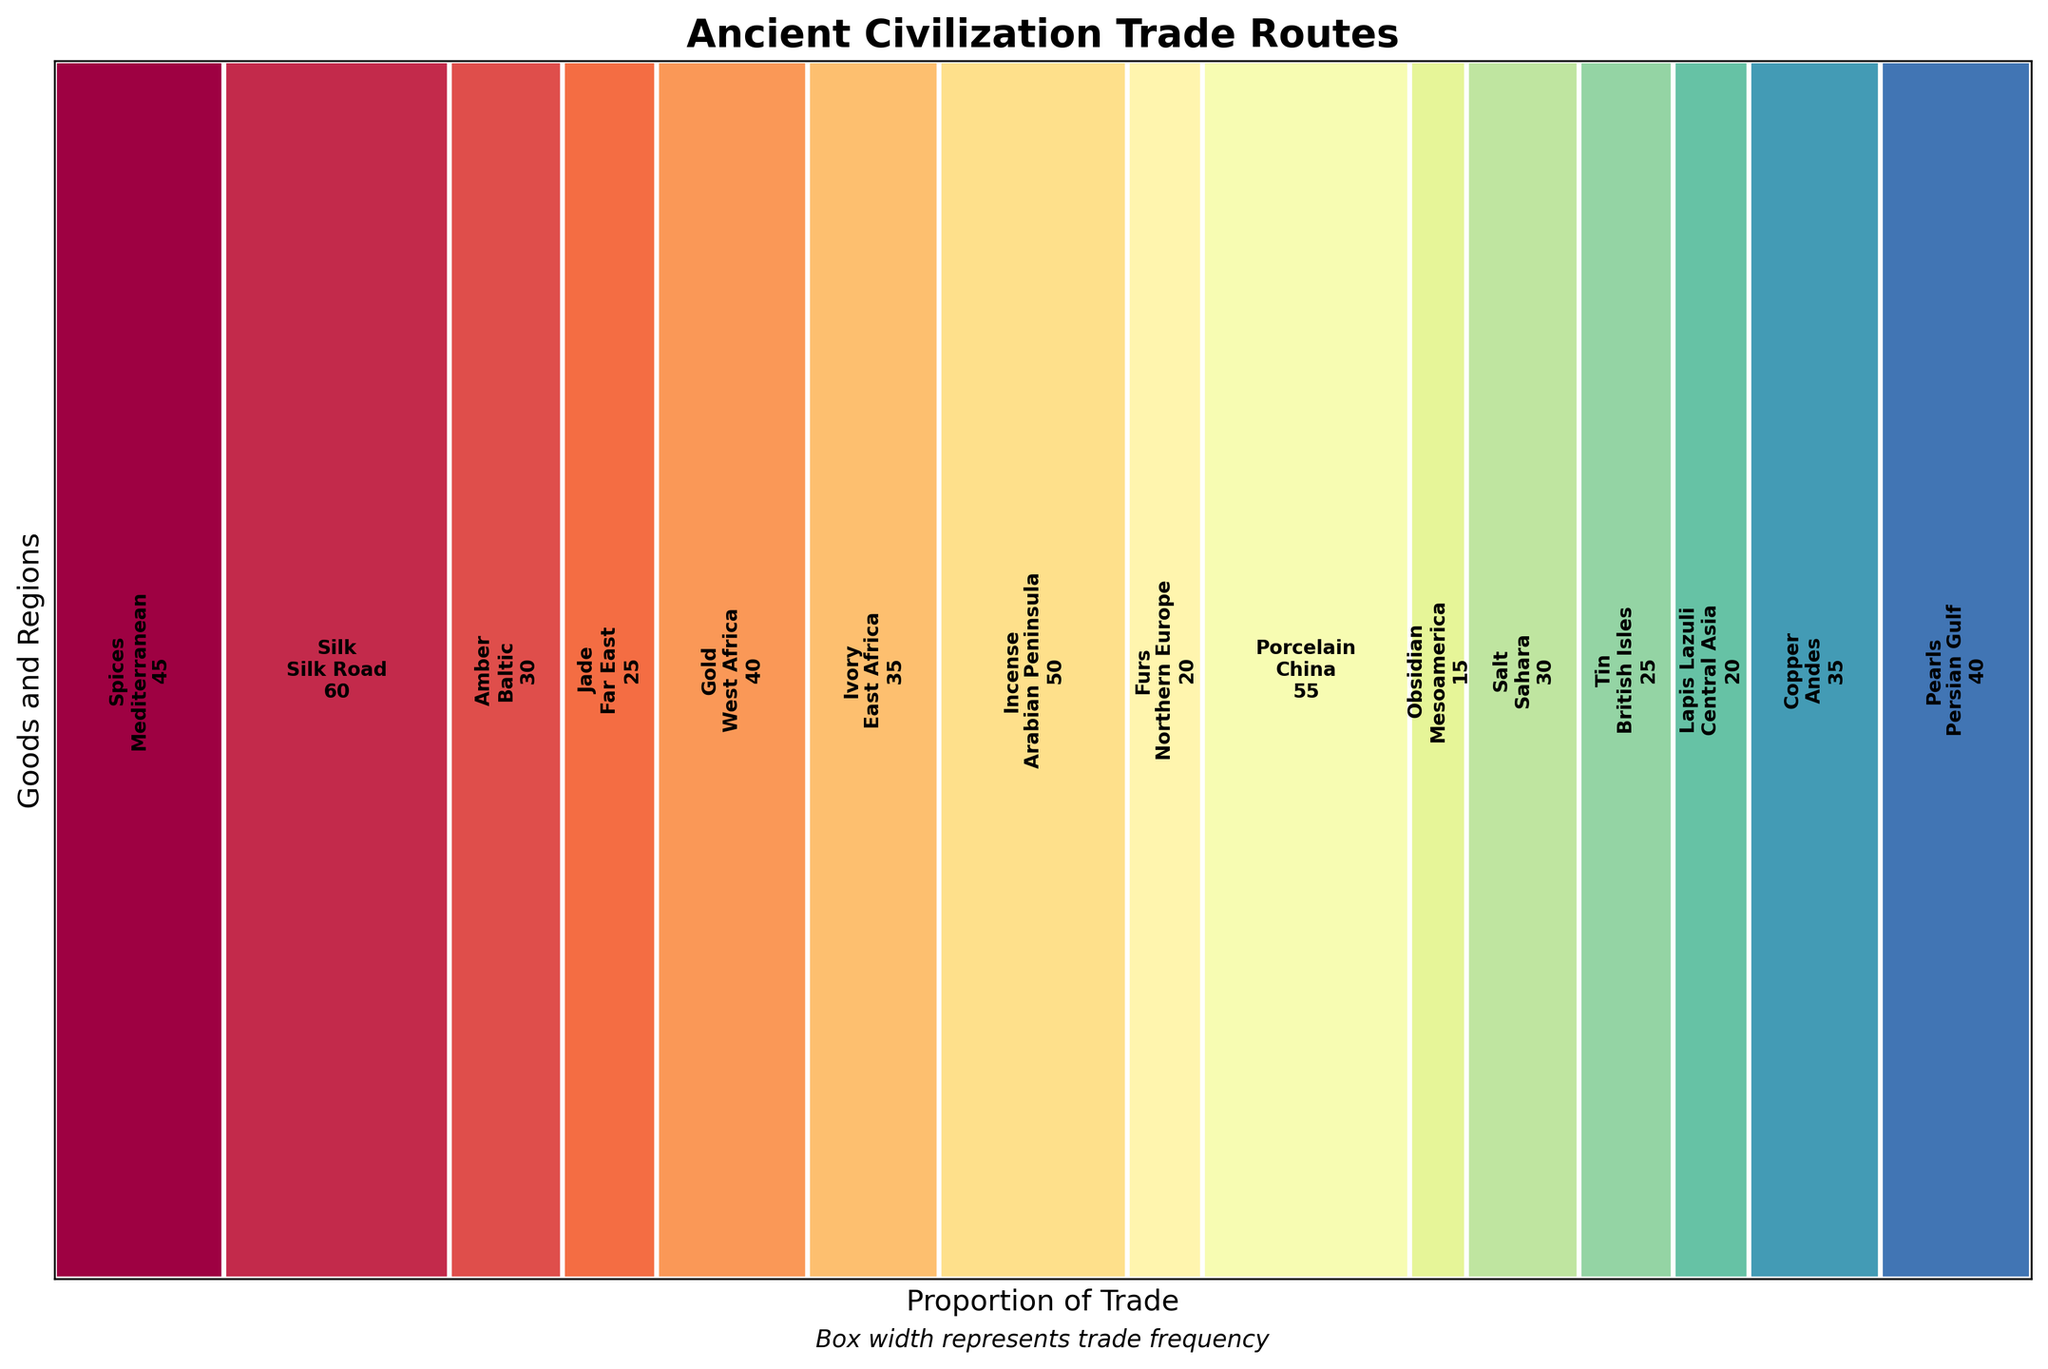Which good is traded the most frequently? The longest rectangle represents the good with the highest trade frequency. This is the Silk on the Silk Road with 60 trades.
Answer: Silk Which goods are traded in European regions? Identify the regions located in or around Europe and then list the associated goods. The goods traded in Mediterranean (Spices), Baltic (Amber), Northern Europe (Furs), and British Isles (Tin) belong to European regions.
Answer: Spices, Amber, Furs, and Tin How many more trades does Porcelain have compared to Obsidian? Determine the trade frequencies for Porcelain (55) and Obsidian (15). Then, calculate the difference: 55 - 15 = 40.
Answer: 40 What is the combined trade frequency for Spices and Gold? Find the frequencies for Spices (45) and Gold (40) and sum them up: 45 + 40 = 85.
Answer: 85 Which goods have the same trade frequency? Look for rectangles of equal width. Copper and Ivory both have a frequency of 35.
Answer: Copper and Ivory Rank the regions by their trade frequency from highest to lowest. List the regions according to the height of their rectangles in descending order: Silk Road (60), China (55), Arabian Peninsula (50), Mediterranean (45), Persian Gulf (40), West Africa (40), East Africa (35), Andes (35), Sahara (30), Baltic (30), Far East (25), British Isles (25), Central Asia (20), Northern Europe (20), Mesoamerica (15).
Answer: Silk Road, China, Arabian Peninsula, Mediterranean, Persian Gulf, West Africa, East Africa, Andes, Sahara, Baltic, Far East, British Isles, Central Asia, Northern Europe, Mesoamerica Which region has a larger trade in terms of frequency, the Andes or Central Asia? Compare the trade frequencies of the Andes (Copper 35) and Central Asia (Lapis Lazuli 20). Andes has a larger frequency.
Answer: Andes Between the Arabian Peninsula and Persia, which has a more significant variety of goods traded? Notice instances of regions mentioned multiple times but with different goods: Only Arabia (Incense) and Persian Gulf (Pearls) are used here and Persia has more frequency but Arabia has more variety.
Answer: Equal in variety What is the total trade frequency for regions starting with the letter "S"? Calculate the total frequency for all regions starting with 'S': Silk Road (60) + Sahara (30) = 90.
Answer: 90 